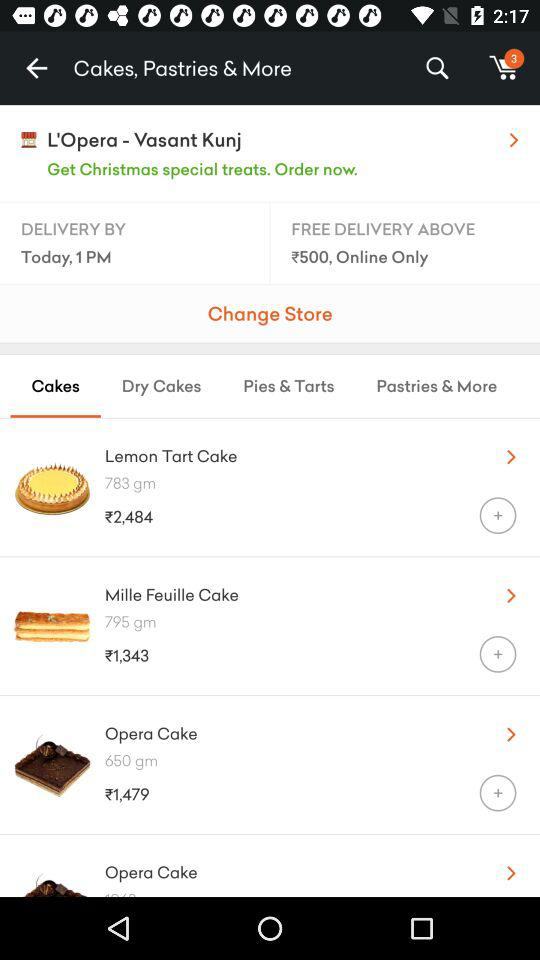How many items are there in the cart? There are 3 items in the cart. 